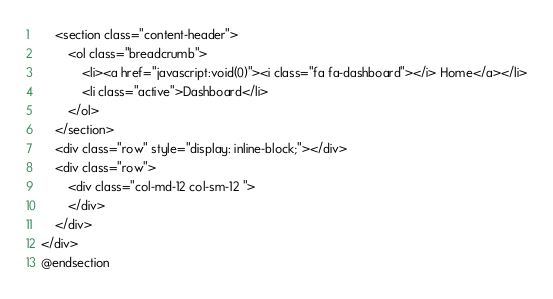<code> <loc_0><loc_0><loc_500><loc_500><_PHP_>    <section class="content-header">
        <ol class="breadcrumb">
            <li><a href="javascript:void(0)"><i class="fa fa-dashboard"></i> Home</a></li>
            <li class="active">Dashboard</li>
        </ol>
    </section>
    <div class="row" style="display: inline-block;"></div>
    <div class="row">
        <div class="col-md-12 col-sm-12 ">
        </div>
    </div>
</div>
@endsection</code> 